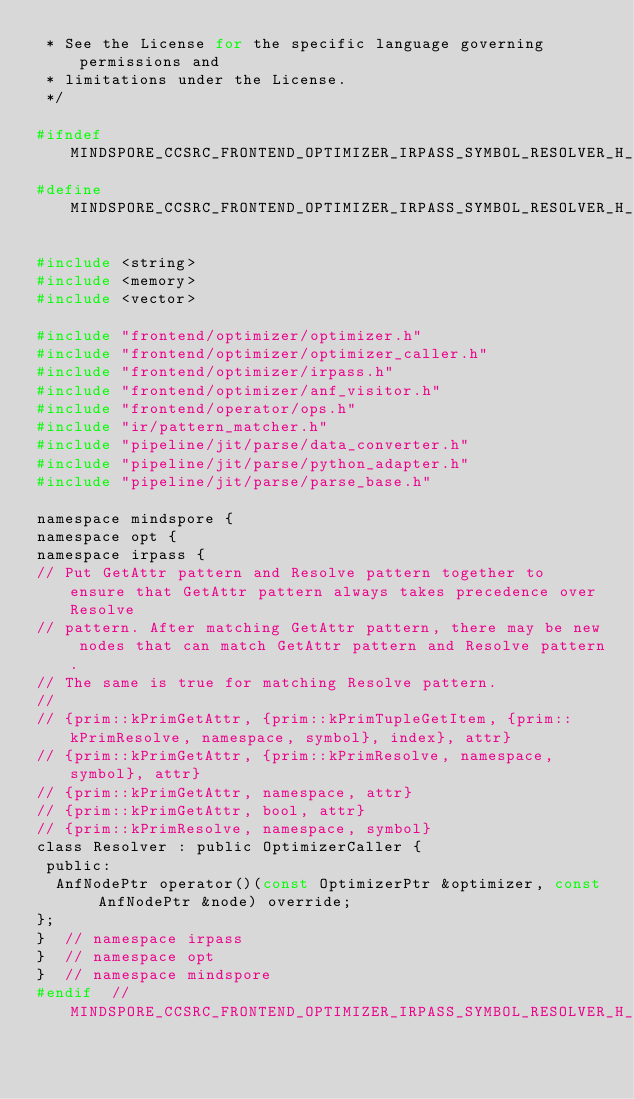Convert code to text. <code><loc_0><loc_0><loc_500><loc_500><_C_> * See the License for the specific language governing permissions and
 * limitations under the License.
 */

#ifndef MINDSPORE_CCSRC_FRONTEND_OPTIMIZER_IRPASS_SYMBOL_RESOLVER_H_
#define MINDSPORE_CCSRC_FRONTEND_OPTIMIZER_IRPASS_SYMBOL_RESOLVER_H_

#include <string>
#include <memory>
#include <vector>

#include "frontend/optimizer/optimizer.h"
#include "frontend/optimizer/optimizer_caller.h"
#include "frontend/optimizer/irpass.h"
#include "frontend/optimizer/anf_visitor.h"
#include "frontend/operator/ops.h"
#include "ir/pattern_matcher.h"
#include "pipeline/jit/parse/data_converter.h"
#include "pipeline/jit/parse/python_adapter.h"
#include "pipeline/jit/parse/parse_base.h"

namespace mindspore {
namespace opt {
namespace irpass {
// Put GetAttr pattern and Resolve pattern together to ensure that GetAttr pattern always takes precedence over Resolve
// pattern. After matching GetAttr pattern, there may be new nodes that can match GetAttr pattern and Resolve pattern.
// The same is true for matching Resolve pattern.
//
// {prim::kPrimGetAttr, {prim::kPrimTupleGetItem, {prim::kPrimResolve, namespace, symbol}, index}, attr}
// {prim::kPrimGetAttr, {prim::kPrimResolve, namespace, symbol}, attr}
// {prim::kPrimGetAttr, namespace, attr}
// {prim::kPrimGetAttr, bool, attr}
// {prim::kPrimResolve, namespace, symbol}
class Resolver : public OptimizerCaller {
 public:
  AnfNodePtr operator()(const OptimizerPtr &optimizer, const AnfNodePtr &node) override;
};
}  // namespace irpass
}  // namespace opt
}  // namespace mindspore
#endif  // MINDSPORE_CCSRC_FRONTEND_OPTIMIZER_IRPASS_SYMBOL_RESOLVER_H_
</code> 